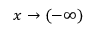<formula> <loc_0><loc_0><loc_500><loc_500>x \to ( - \infty )</formula> 